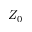Convert formula to latex. <formula><loc_0><loc_0><loc_500><loc_500>Z _ { 0 }</formula> 